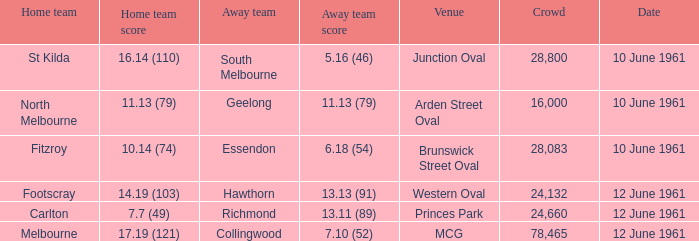What was the home team score for the Richmond away team? 7.7 (49). 